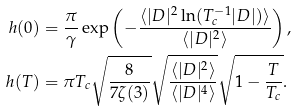<formula> <loc_0><loc_0><loc_500><loc_500>h ( 0 ) & = \frac { \pi } { \gamma } \exp \left ( - \frac { \langle | D | ^ { 2 } \ln ( T _ { c } ^ { - 1 } | D | ) \rangle } { \langle | D | ^ { 2 } \rangle } \right ) , \\ h ( T ) & = \pi T _ { c } \sqrt { \frac { 8 } { 7 \zeta ( 3 ) } } \sqrt { \frac { \langle | D | ^ { 2 } \rangle } { \langle | D | ^ { 4 } \rangle } } \sqrt { 1 - \frac { T } { T _ { c } } } .</formula> 